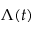Convert formula to latex. <formula><loc_0><loc_0><loc_500><loc_500>\Lambda ( t )</formula> 